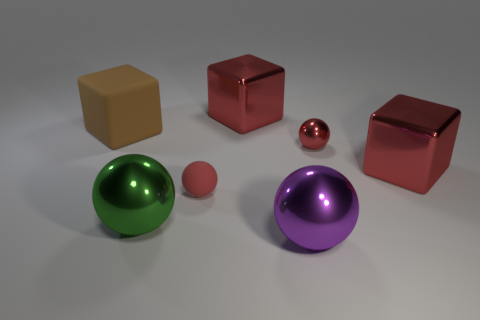Subtract all red blocks. How many blocks are left? 1 Subtract all red balls. How many balls are left? 2 Add 1 large red things. How many objects exist? 8 Subtract all spheres. How many objects are left? 3 Subtract all cyan balls. Subtract all blue cylinders. How many balls are left? 4 Subtract all cyan cylinders. How many blue blocks are left? 0 Subtract all green shiny balls. Subtract all tiny red rubber balls. How many objects are left? 5 Add 3 small red metallic spheres. How many small red metallic spheres are left? 4 Add 2 purple things. How many purple things exist? 3 Subtract 0 yellow cylinders. How many objects are left? 7 